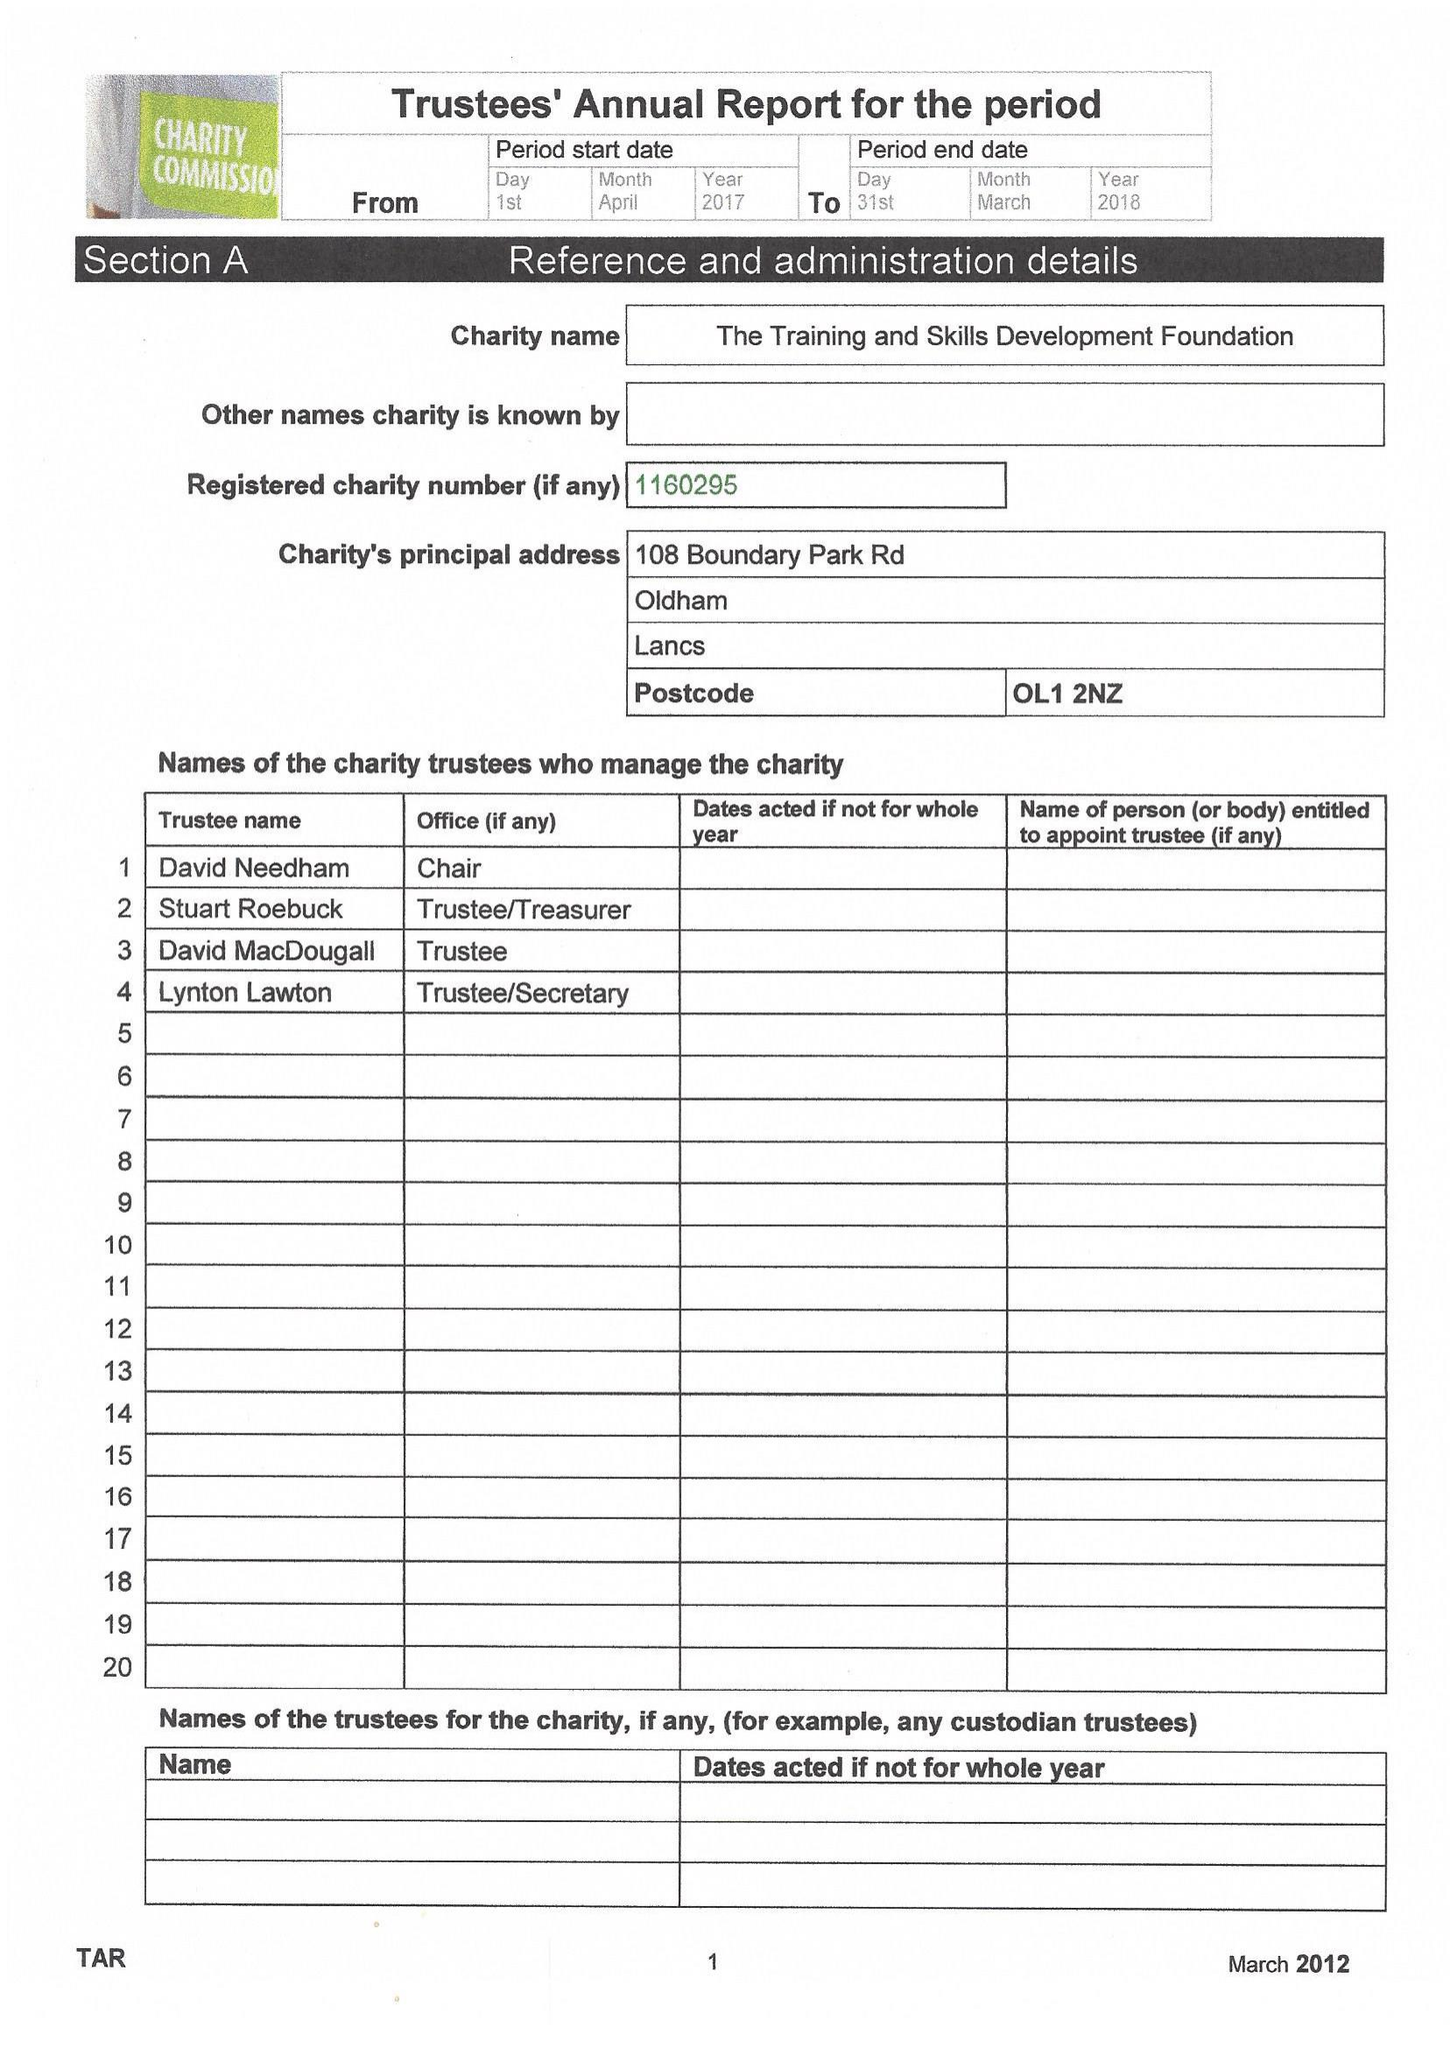What is the value for the income_annually_in_british_pounds?
Answer the question using a single word or phrase. 17313.00 